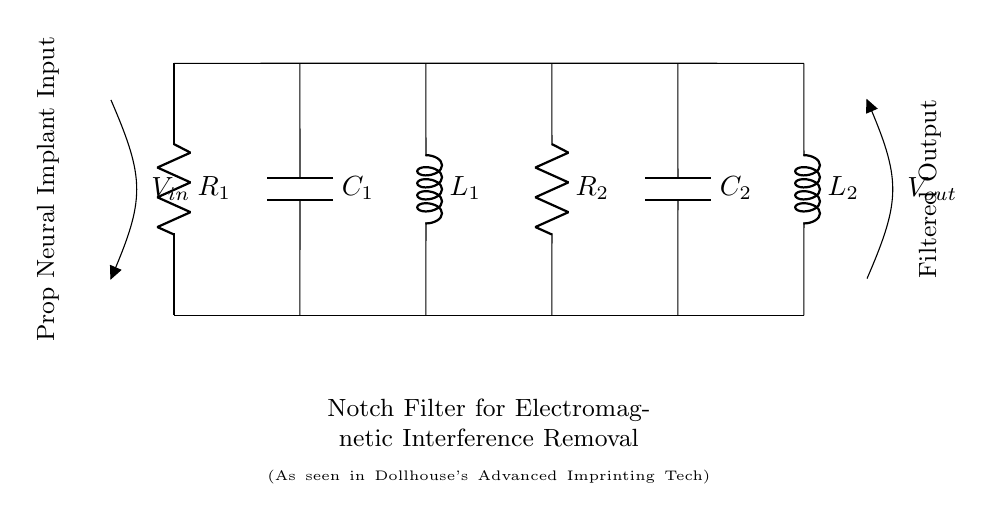What type of circuit is this? This circuit is specifically designed as a notch filter, which is meant to eliminate unwanted frequencies (in this case, electromagnetic interference). The designation in the title confirms its function.
Answer: notch filter What components are present in the circuit? The circuit includes resistors, capacitors, and inductors as its components, as seen in the listed labels (R1, R2, C1, C2, L1, L2).
Answer: resistors, capacitors, and inductors What is the input of the circuit labeled as? The input is labeled as V_in, indicating the voltage input into the circuit. The notation shows that it is connected before the filtering process begins.
Answer: V_in How many inductors are used in the design? There are two inductors present in the diagram, labeled as L1 and L2, indicating the specific components used for filtering the signal.
Answer: 2 What is the purpose of this circuit? The purpose of the circuit is to remove unwanted electromagnetic interference from the neural implant devices, which is explicitly stated in the circuit description.
Answer: remove electromagnetic interference Which component appears to be connected to the output? The output is labeled as V_out, indicating that the filtered voltage is taken from this point in the circuit after processing the input.
Answer: V_out What is the significance of the label "Prop Neural Implant Input"? This label signifies that the input voltage is representative of a prop neural implant device, giving context to the filter's application in that scenario.
Answer: context of prop neural implant 